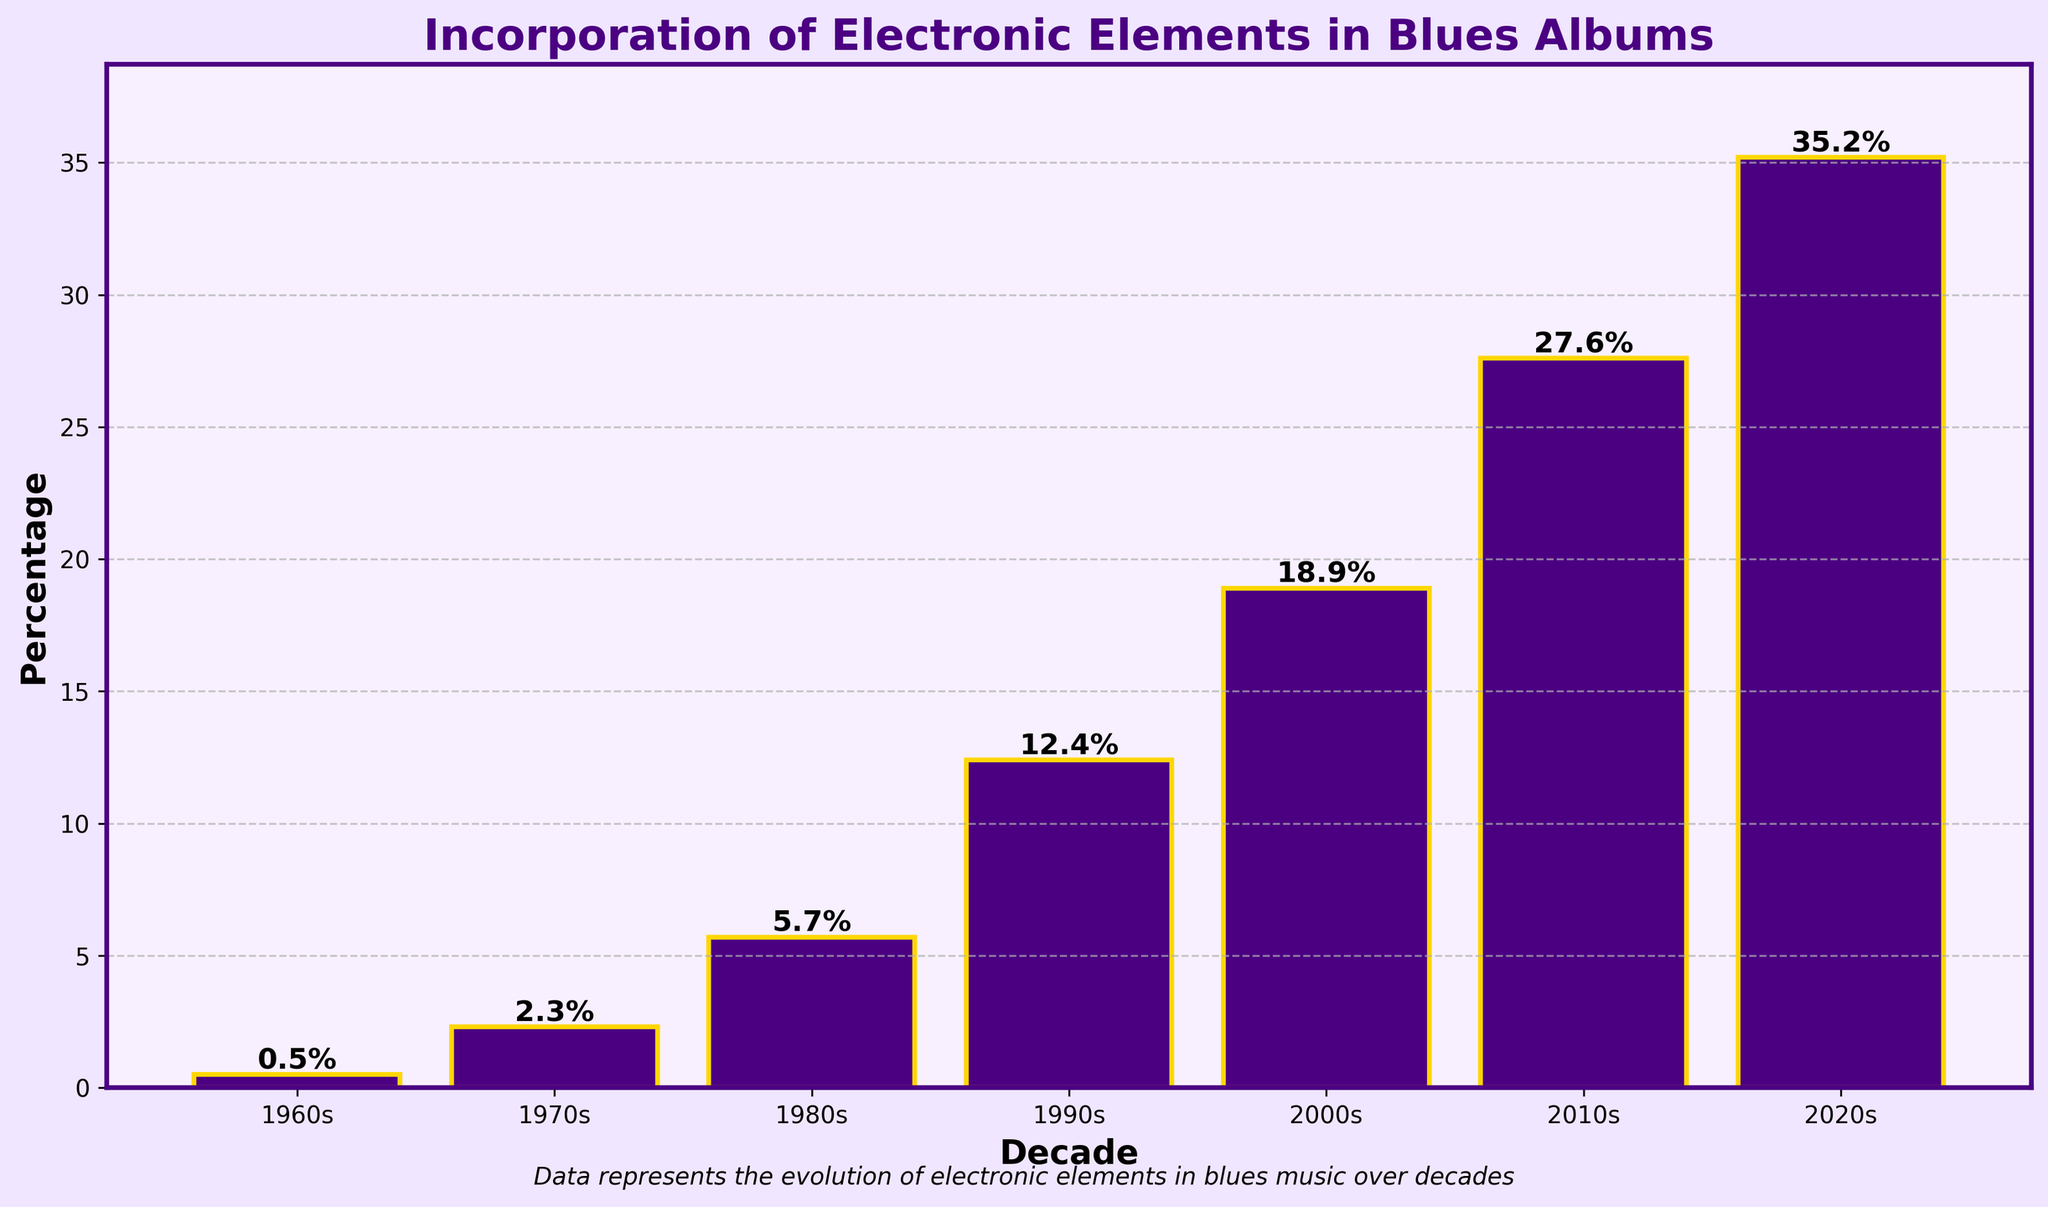What's the percentage of blues albums incorporating electronic elements in the 1990s? Look at the bar corresponding to the 1990s decade, which indicates the value of the percentage.
Answer: 12.4% Which decade has the highest percentage of blues albums incorporating electronic elements? Identify the tallest bar in the chart, which represents the decade with the highest percentage.
Answer: 2020s Is the percentage of blues albums incorporating electronic elements in the 2010s more than double that in the 2000s? Compare the height of the bar for the 2010s to twice the height of the bar for the 2000s. The bar for the 2010s (27.6%) is indeed more than double the bar for the 2000s (18.9% x 2 = 37.8%).
Answer: No What is the total percentage increase in blues albums incorporating electronic elements from the 1960s to the 2020s? Subtract the percentage in the 1960s from the percentage in the 2020s to find the increase: 35.2% - 0.5% = 34.7%.
Answer: 34.7% Which decades have a percentage less than 10%? Identify the bars with heights less than 10%. These are the 1960s (0.5%), 1970s (2.3%), and 1980s (5.7%).
Answer: 1960s, 1970s, 1980s Between which consecutive decades is the largest increase in percentage observed? Determine the differences between each pair of consecutive decades and identify the largest: 1990s to 2000s (18.9% - 12.4% = 6.5%), and 2010s to 2020s (35.2% - 27.6% = 7.6%). The largest difference is between the 2010s and 2020s.
Answer: 2010s to 2020s What percentage of blues albums incorporated electronic elements in the 2000s, and how does that compare to the 1970s? Retrieve the percentages for the 2000s (18.9%) and the 1970s (2.3%) and compare: 18.9% is much higher than 2.3%.
Answer: 2000s: 18.9%, much higher than 1970s: 2.3% How much more is the percentage in the 2020s compared to the 1980s? Subtract the percentage in the 1980s from the percentage in the 2020s: 35.2% - 5.7% = 29.5%.
Answer: 29.5% What trend does the plot show about the incorporation of electronic elements in blues albums over the decades? The heights of the bars increase consistently from the 1960s to the 2020s, indicating a growing trend in the incorporation of electronic elements.
Answer: Increasing trend 